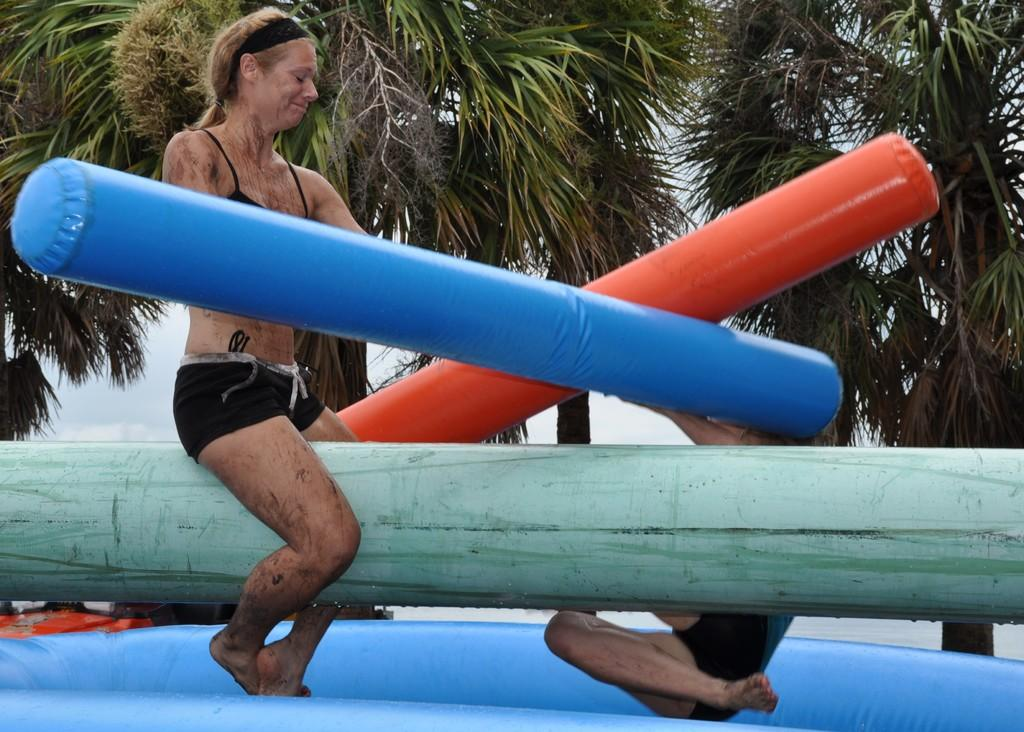What are the two people doing in the image? The two people are on an inflatable in the image. What is the woman doing in the image? The woman is sitting on a pole in the image. How many poles can be seen in the image? There are poles visible in the image. What type of vegetation is present in the image? There is a group of trees in the image. What is the condition of the sky in the image? The sky is visible in the image and appears cloudy. What offer is the woman making to the trees in the image? There is no indication in the image that the woman is making an offer to the trees. What type of writing can be seen on the inflatable in the image? There is no writing visible on the inflatable in the image. 